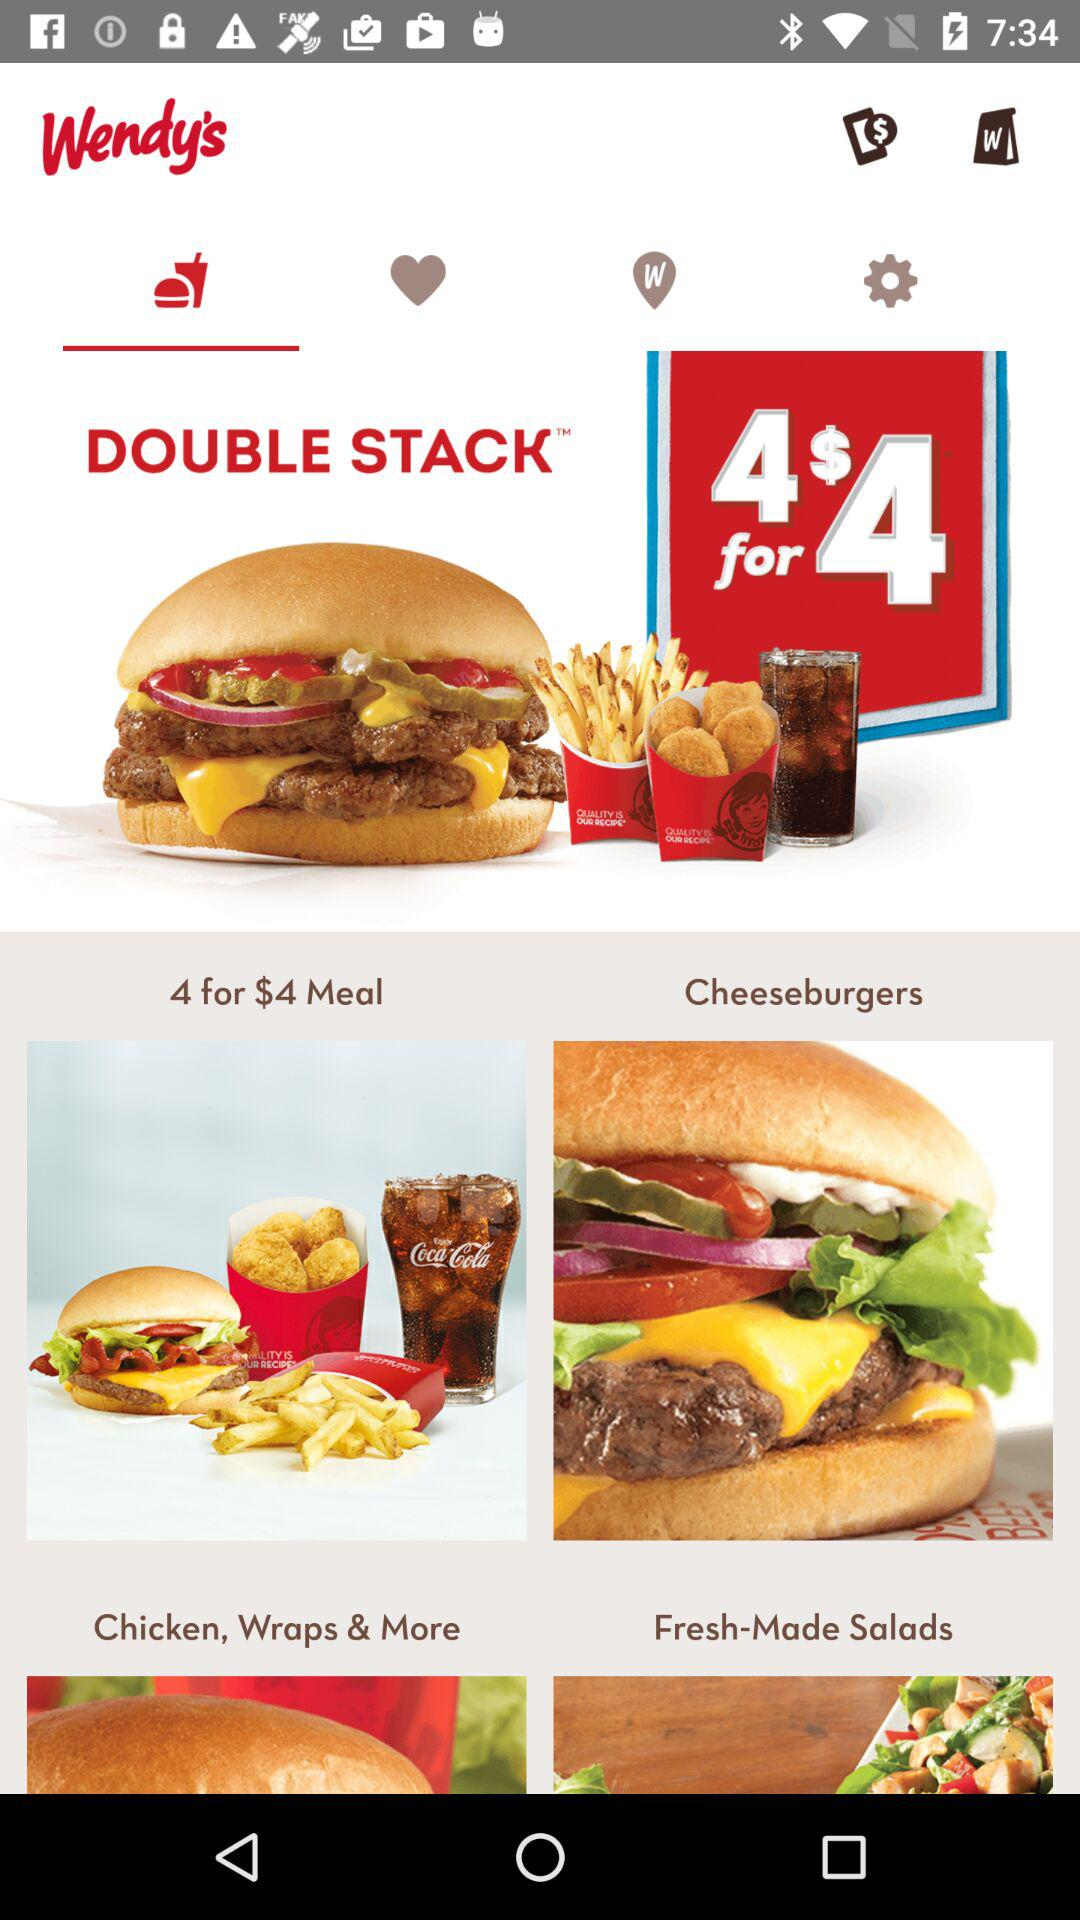What are the items in the menu? The items in the menu are "4 for $4 Meal", "Cheeseburgers", "Chicken, Wraps & More" and "Fresh-Made Salads". 